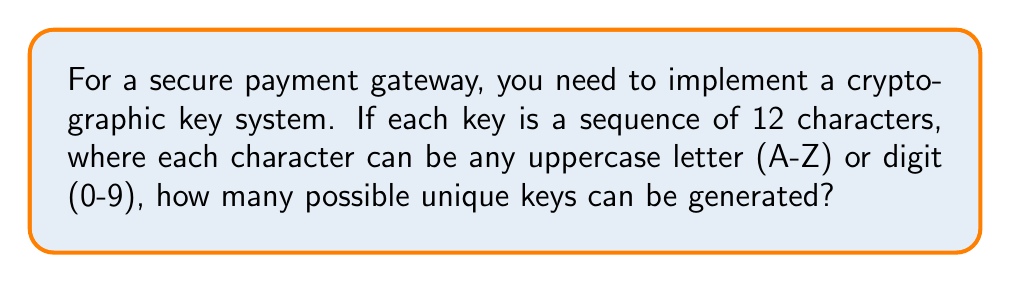Can you solve this math problem? Let's approach this step-by-step:

1) First, we need to determine the number of possible characters for each position in the key:
   - There are 26 uppercase letters (A-Z)
   - There are 10 digits (0-9)
   - Total number of possible characters: $26 + 10 = 36$

2) Now, for each of the 12 positions in the key, we have 36 choices.

3) This is a case of counting with replacement, as the same character can be used multiple times in the key.

4) When we have $n$ choices for each of $k$ positions, and choices can be repeated, the total number of possibilities is $n^k$.

5) In this case, we have:
   $n = 36$ (possible characters)
   $k = 12$ (length of the key)

6) Therefore, the total number of possible keys is:

   $$36^{12}$$

7) Calculating this:
   $$36^{12} = 4,738,381,338,321,616,896$$

This extremely large number demonstrates why such a key system would be secure against brute-force attacks.
Answer: $36^{12} = 4,738,381,338,321,616,896$ 